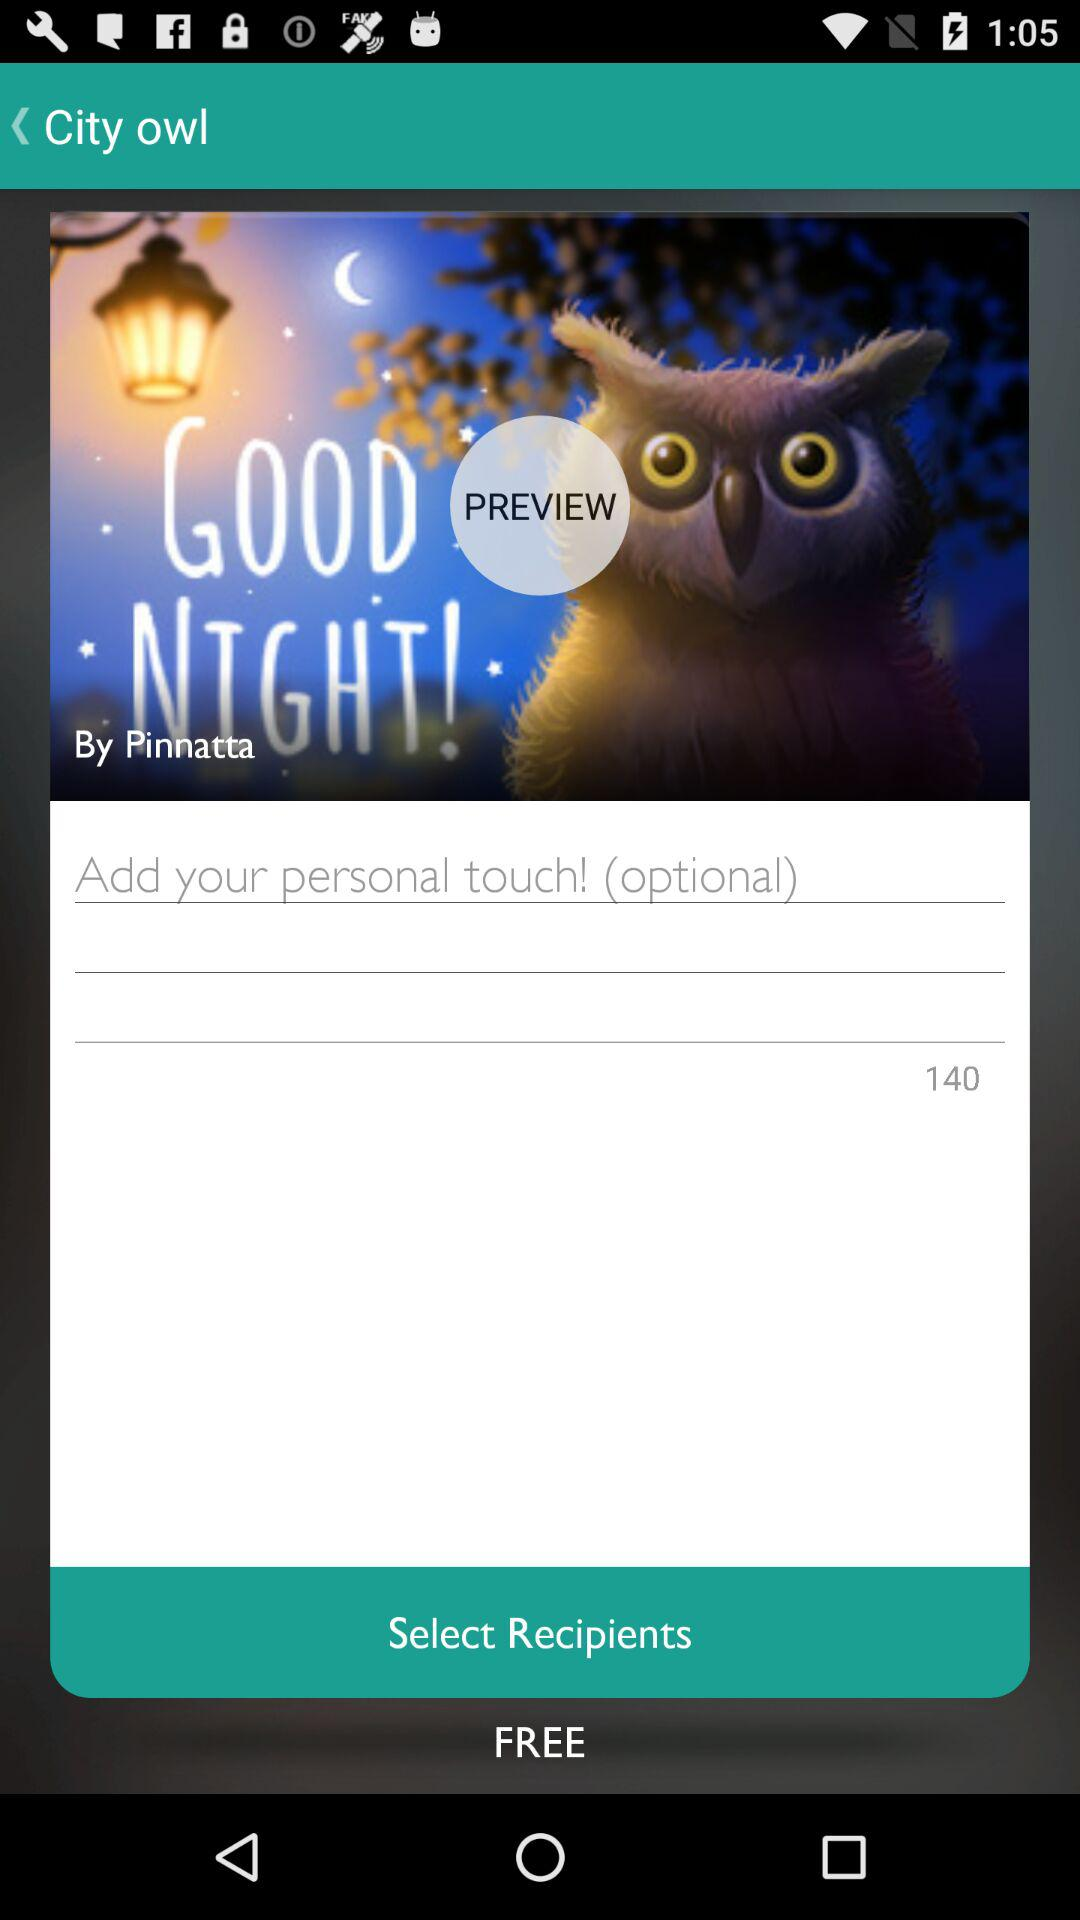Who is the writer?
When the provided information is insufficient, respond with <no answer>. <no answer> 